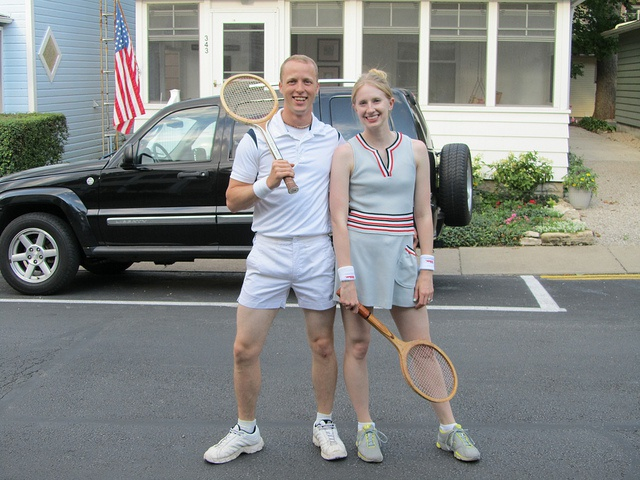Describe the objects in this image and their specific colors. I can see car in white, black, darkgray, gray, and lightgray tones, people in white, lavender, darkgray, and gray tones, people in white, darkgray, and gray tones, tennis racket in white, darkgray, tan, and gray tones, and tennis racket in white, darkgray, lightgray, and tan tones in this image. 